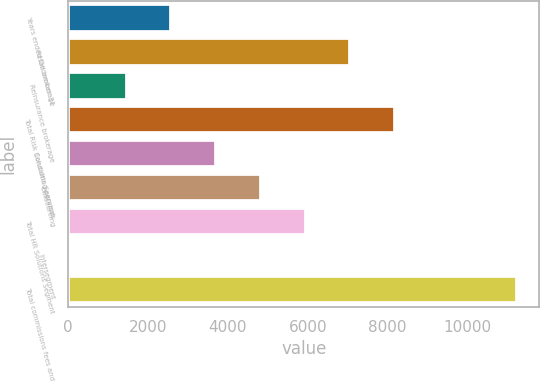Convert chart to OTSL. <chart><loc_0><loc_0><loc_500><loc_500><bar_chart><fcel>Years ended December 31<fcel>Retail brokerage<fcel>Reinsurance brokerage<fcel>Total Risk Solutions Segment<fcel>Consulting services<fcel>Outsourcing<fcel>Total HR Solutions Segment<fcel>Intersegment<fcel>Total commissions fees and<nl><fcel>2583.4<fcel>7065<fcel>1463<fcel>8185.4<fcel>3703.8<fcel>4824.2<fcel>5944.6<fcel>31<fcel>11235<nl></chart> 